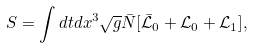<formula> <loc_0><loc_0><loc_500><loc_500>S = \int d t d x ^ { 3 } \sqrt { g } \bar { N } [ \bar { \mathcal { L } } _ { 0 } + \mathcal { L } _ { 0 } + \mathcal { L } _ { 1 } ] ,</formula> 